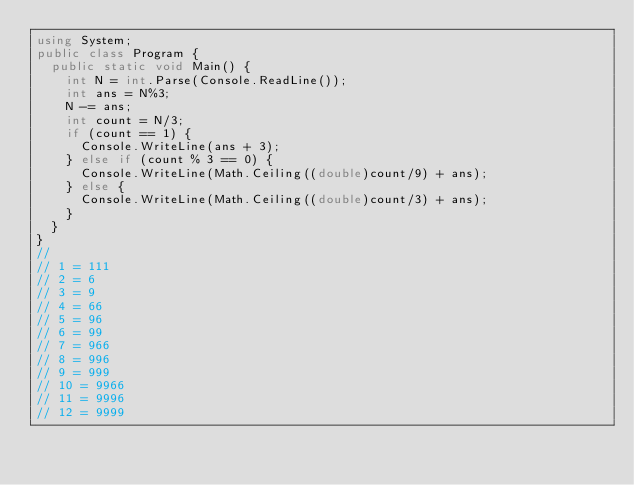Convert code to text. <code><loc_0><loc_0><loc_500><loc_500><_C#_>using System;
public class Program {
  public static void Main() {
    int N = int.Parse(Console.ReadLine());
    int ans = N%3;
    N -= ans;
    int count = N/3;
    if (count == 1) {
      Console.WriteLine(ans + 3);
    } else if (count % 3 == 0) {
      Console.WriteLine(Math.Ceiling((double)count/9) + ans);
    } else {
      Console.WriteLine(Math.Ceiling((double)count/3) + ans);
    }
  }
}
//
// 1 = 111
// 2 = 6
// 3 = 9
// 4 = 66
// 5 = 96
// 6 = 99
// 7 = 966
// 8 = 996
// 9 = 999
// 10 = 9966
// 11 = 9996
// 12 = 9999</code> 